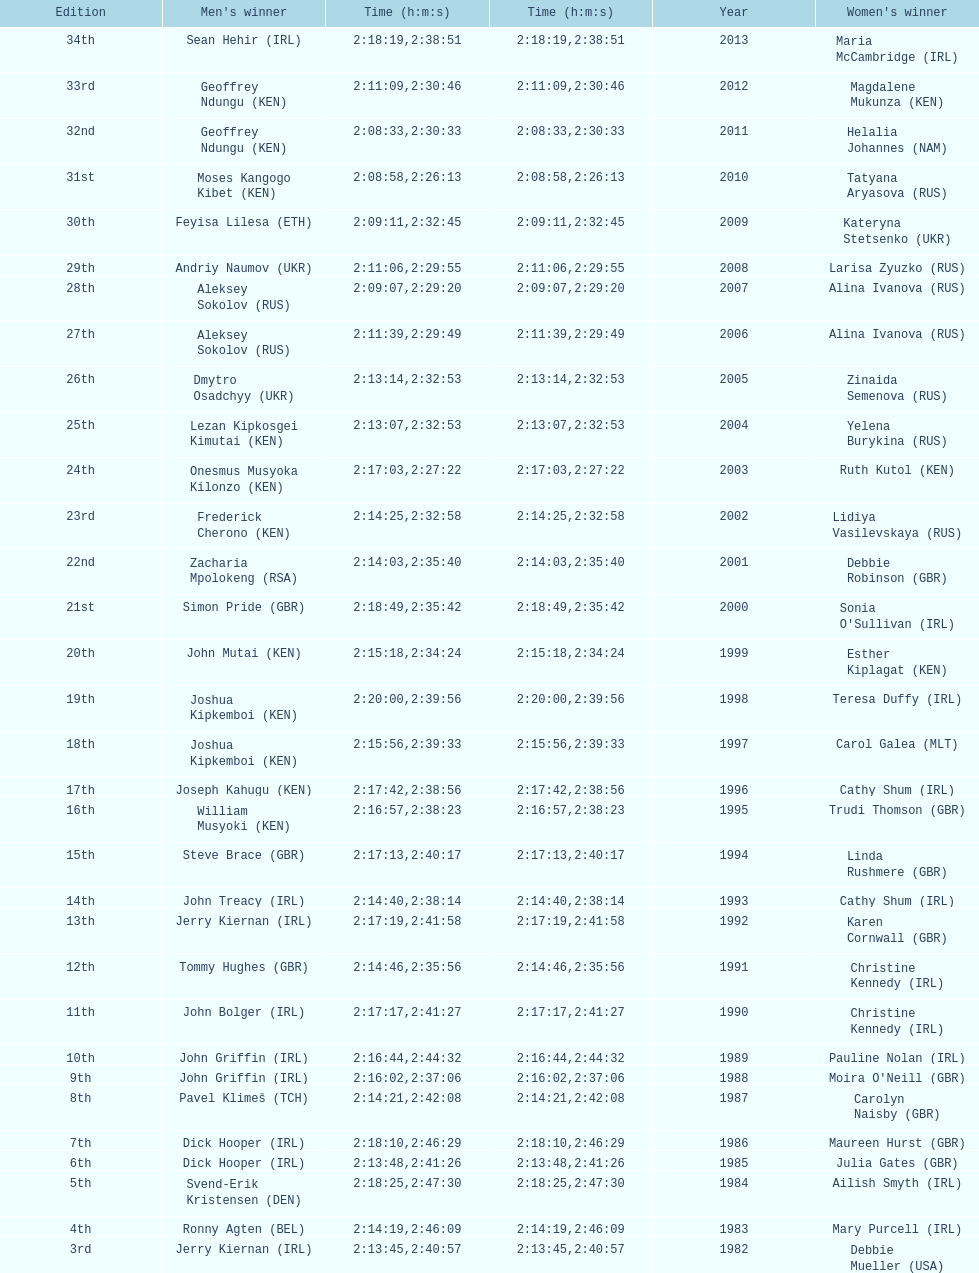Who won at least 3 times in the mens? Dick Hooper (IRL). 